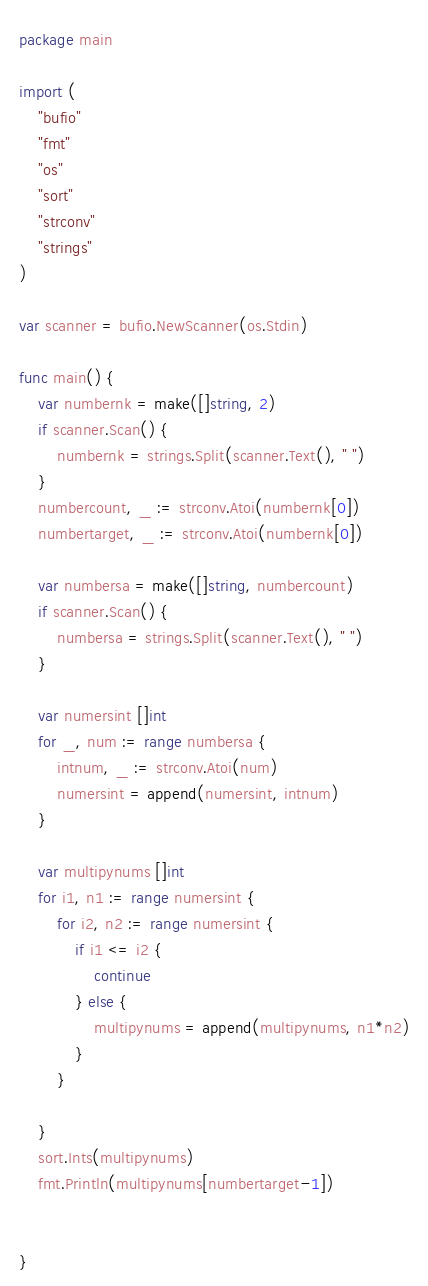Convert code to text. <code><loc_0><loc_0><loc_500><loc_500><_Go_>package main

import (
	"bufio"
	"fmt"
	"os"
	"sort"
	"strconv"
	"strings"
)

var scanner = bufio.NewScanner(os.Stdin)

func main() {
	var numbernk = make([]string, 2)
	if scanner.Scan() {
		numbernk = strings.Split(scanner.Text(), " ")
	}
	numbercount, _ := strconv.Atoi(numbernk[0])
	numbertarget, _ := strconv.Atoi(numbernk[0])

	var numbersa = make([]string, numbercount)
	if scanner.Scan() {
		numbersa = strings.Split(scanner.Text(), " ")
	}

	var numersint []int
	for _, num := range numbersa {
		intnum, _ := strconv.Atoi(num)
		numersint = append(numersint, intnum)
	}

	var multipynums []int
	for i1, n1 := range numersint {
		for i2, n2 := range numersint {
			if i1 <= i2 {
				continue
			} else {
				multipynums = append(multipynums, n1*n2)
			}
		}

	}
	sort.Ints(multipynums)
	fmt.Println(multipynums[numbertarget-1])


}
</code> 